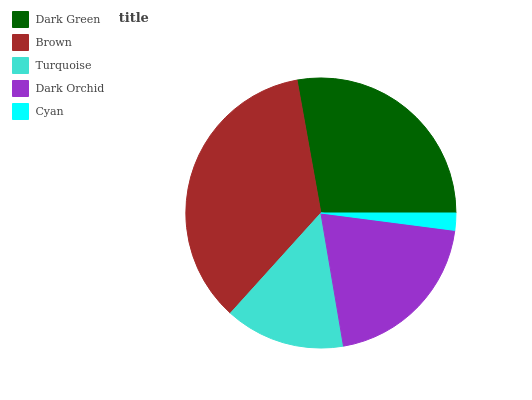Is Cyan the minimum?
Answer yes or no. Yes. Is Brown the maximum?
Answer yes or no. Yes. Is Turquoise the minimum?
Answer yes or no. No. Is Turquoise the maximum?
Answer yes or no. No. Is Brown greater than Turquoise?
Answer yes or no. Yes. Is Turquoise less than Brown?
Answer yes or no. Yes. Is Turquoise greater than Brown?
Answer yes or no. No. Is Brown less than Turquoise?
Answer yes or no. No. Is Dark Orchid the high median?
Answer yes or no. Yes. Is Dark Orchid the low median?
Answer yes or no. Yes. Is Dark Green the high median?
Answer yes or no. No. Is Brown the low median?
Answer yes or no. No. 